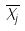<formula> <loc_0><loc_0><loc_500><loc_500>\overline { X _ { j } }</formula> 